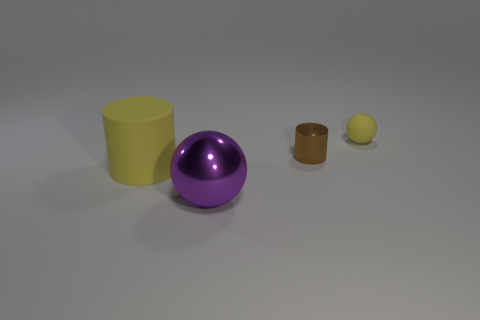Add 2 rubber spheres. How many objects exist? 6 Add 2 tiny yellow rubber spheres. How many tiny yellow rubber spheres exist? 3 Subtract 0 cyan blocks. How many objects are left? 4 Subtract all big purple metallic things. Subtract all small objects. How many objects are left? 1 Add 4 rubber cylinders. How many rubber cylinders are left? 5 